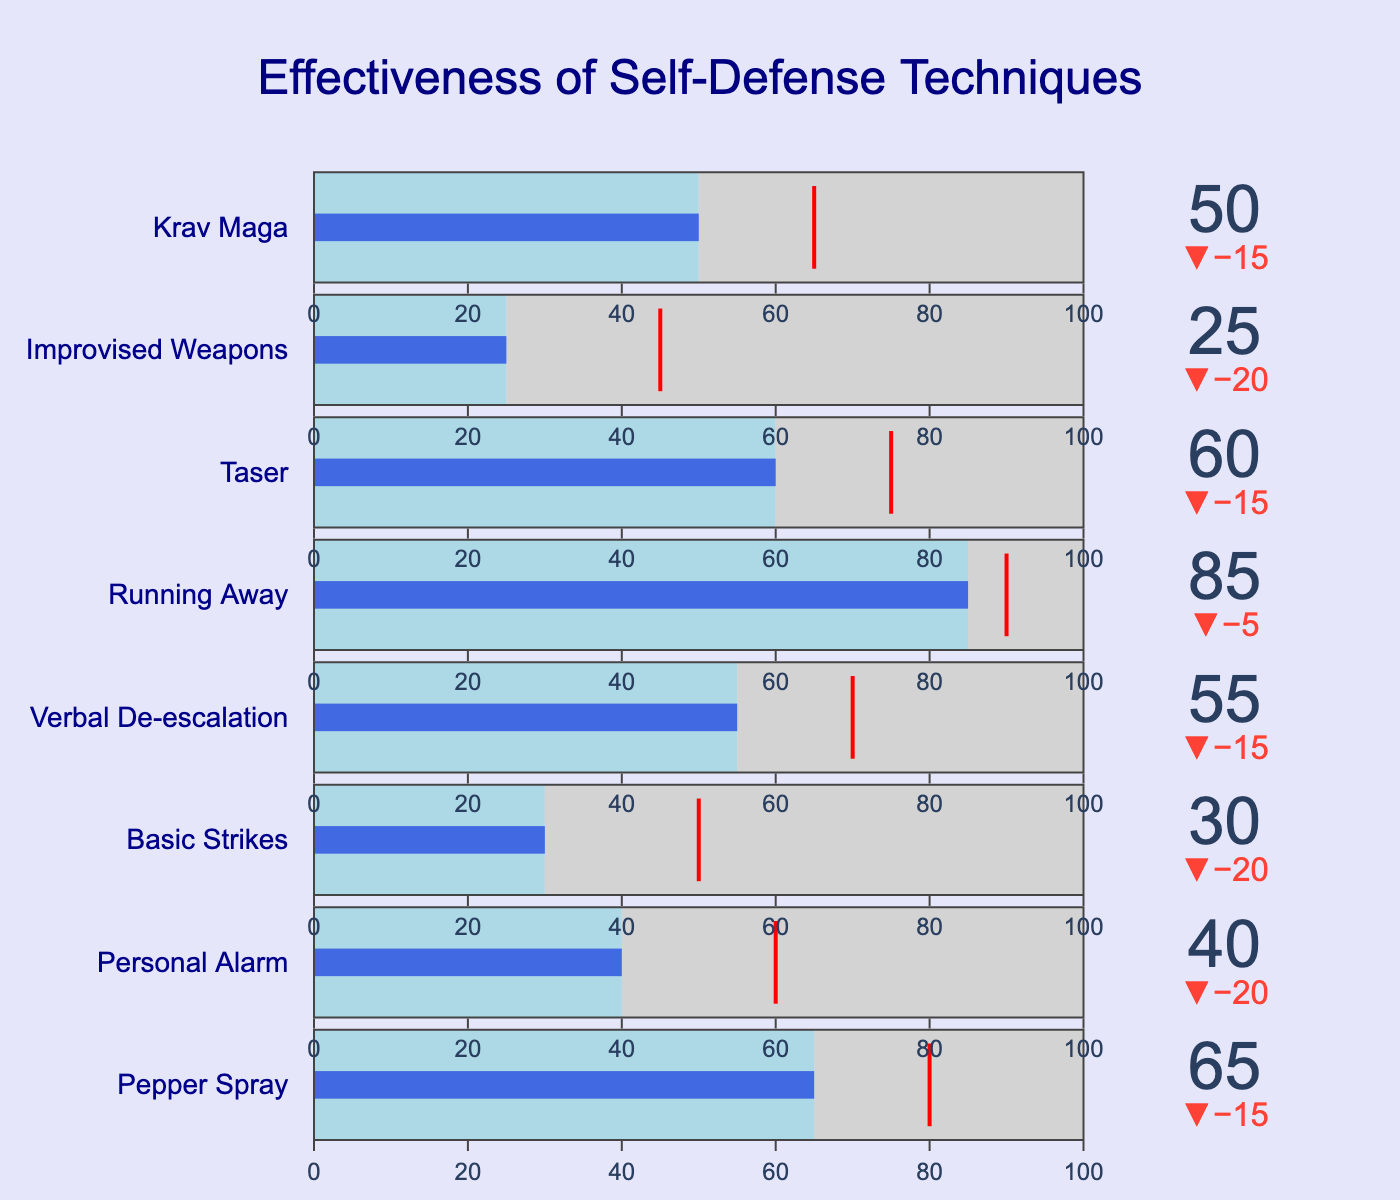What is the title of the figure? The title is usually placed at the top of the figure and is explicitly written.
Answer: "Effectiveness of Self-Defense Techniques" What is the effectiveness value of Pepper Spray? The effectiveness value is shown directly next to or within the bullet gauge for Pepper Spray in the visual.
Answer: 65 Which self-defense technique has the highest effectiveness value? To determine this, compare the effectiveness values of all techniques and identify the maximum value. Running Away has the highest effectiveness value of 85.
Answer: Running Away How does the effectiveness of Taser compare to its target value? The bullet chart shows both the effectiveness value of Taser and its target value. Compare these two values. Taser's effectiveness is 60, and its target is 75, meaning it falls short by 15.
Answer: Taser's effectiveness is 15 less than its target What is the average effectiveness of all techniques? Add up the effectiveness values of all techniques and divide by the number of techniques. Sum = 65 + 40 + 30 + 55 + 85 + 60 + 25 + 50 = 410. Number of techniques = 8. Average = 410 / 8 = 51.25.
Answer: 51.25 Which technique has the largest gap between its effectiveness and target value? Calculate the absolute difference between effectiveness and target values for each technique. The largest difference appears for Running Away with a gap of 85 - 90 = -5, but we need the largest absolute value. The biggest gap of absolute difference is Improvised Weapons with 45 - 25 = 20.
Answer: Improvised Weapons How many techniques have an effectiveness greater than 50? Count the number of techniques with effectiveness values greater than 50. They are Pepper Spray, Verbal De-escalation, Running Away, and Taser.
Answer: Four techniques What is the range of values for each bullet gauge? The range for each bullet gauge is provided in the data as a common value of 100 for all techniques, which is also visible in the visual axes.
Answer: 0 to 100 What color represents values up to the effectiveness in the bullet gauge? The light blue color represents values up to the effectiveness, which fills up to the effectiveness value in the bullet gauge.
Answer: Light blue 